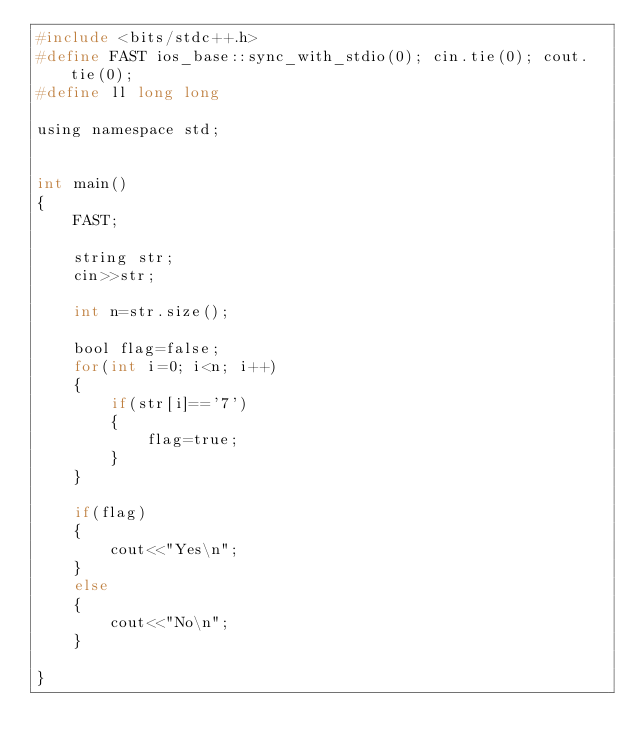Convert code to text. <code><loc_0><loc_0><loc_500><loc_500><_C_>#include <bits/stdc++.h>
#define FAST ios_base::sync_with_stdio(0); cin.tie(0); cout.tie(0);
#define ll long long

using namespace std;


int main()
{
    FAST;
    
    string str;
    cin>>str;
    
    int n=str.size();
    
    bool flag=false;
    for(int i=0; i<n; i++)
    {
        if(str[i]=='7')
        {
            flag=true;
        }
    }
    
    if(flag)
    {
        cout<<"Yes\n";
    }
    else
    {
        cout<<"No\n";
    }
    
}</code> 